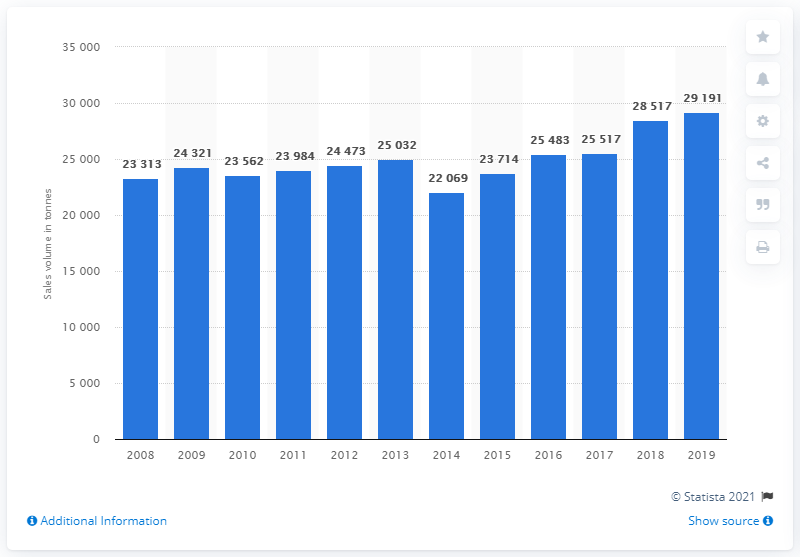Mention a couple of crucial points in this snapshot. In 2019, the sales volume of roasted coffee in the UK was 29,191 units. 